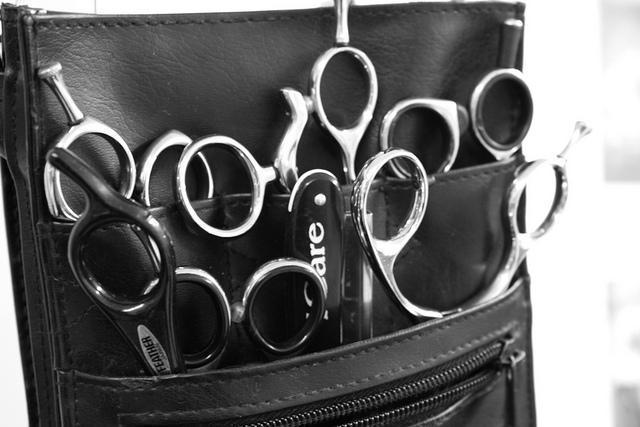What animal might the black item have come from?
Pick the correct solution from the four options below to address the question.
Options: Rabbit, fish, goat, cow. Cow. 